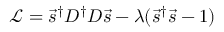Convert formula to latex. <formula><loc_0><loc_0><loc_500><loc_500>\mathcal { L } = \vec { s } ^ { \dagger } D ^ { \dagger } D \vec { s } - \lambda ( \vec { s } ^ { \dagger } \vec { s } - 1 )</formula> 